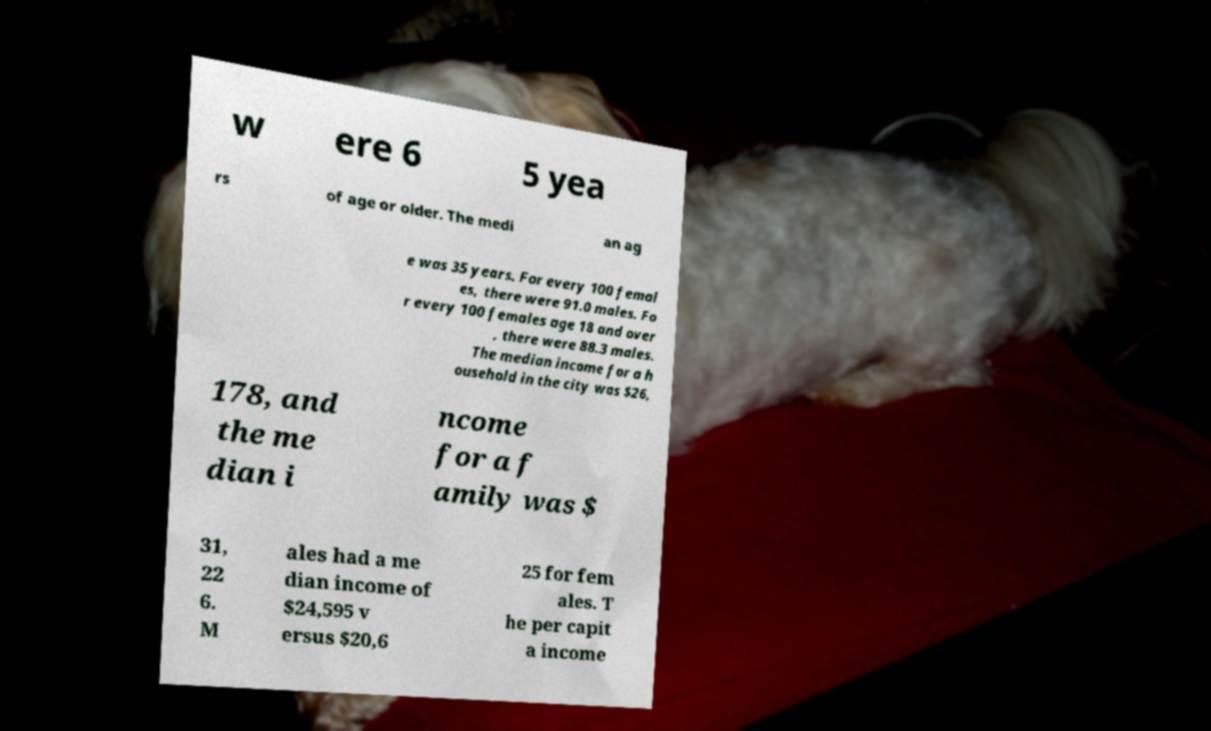Could you extract and type out the text from this image? w ere 6 5 yea rs of age or older. The medi an ag e was 35 years. For every 100 femal es, there were 91.0 males. Fo r every 100 females age 18 and over , there were 88.3 males. The median income for a h ousehold in the city was $26, 178, and the me dian i ncome for a f amily was $ 31, 22 6. M ales had a me dian income of $24,595 v ersus $20,6 25 for fem ales. T he per capit a income 